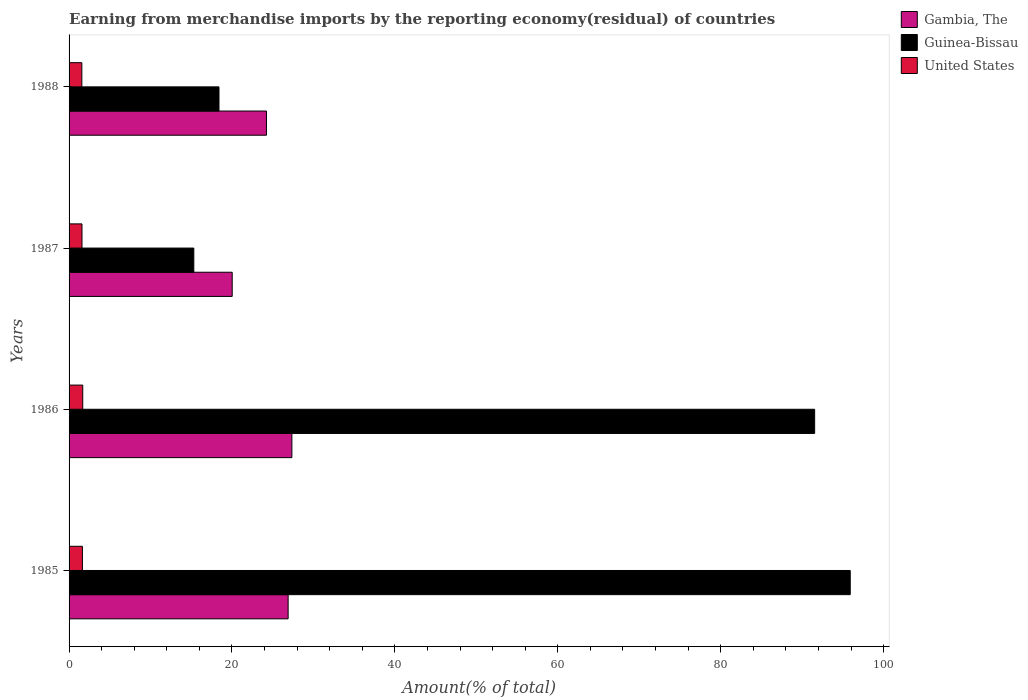How many different coloured bars are there?
Provide a short and direct response. 3. How many groups of bars are there?
Ensure brevity in your answer.  4. Are the number of bars per tick equal to the number of legend labels?
Your answer should be compact. Yes. Are the number of bars on each tick of the Y-axis equal?
Provide a succinct answer. Yes. How many bars are there on the 1st tick from the bottom?
Provide a short and direct response. 3. In how many cases, is the number of bars for a given year not equal to the number of legend labels?
Ensure brevity in your answer.  0. What is the percentage of amount earned from merchandise imports in Gambia, The in 1986?
Offer a terse response. 27.36. Across all years, what is the maximum percentage of amount earned from merchandise imports in United States?
Provide a short and direct response. 1.68. Across all years, what is the minimum percentage of amount earned from merchandise imports in United States?
Offer a terse response. 1.57. In which year was the percentage of amount earned from merchandise imports in United States minimum?
Offer a terse response. 1988. What is the total percentage of amount earned from merchandise imports in Guinea-Bissau in the graph?
Ensure brevity in your answer.  221.15. What is the difference between the percentage of amount earned from merchandise imports in United States in 1985 and that in 1986?
Make the answer very short. -0.04. What is the difference between the percentage of amount earned from merchandise imports in Gambia, The in 1988 and the percentage of amount earned from merchandise imports in Guinea-Bissau in 1986?
Offer a very short reply. -67.3. What is the average percentage of amount earned from merchandise imports in Gambia, The per year?
Give a very brief answer. 24.63. In the year 1985, what is the difference between the percentage of amount earned from merchandise imports in United States and percentage of amount earned from merchandise imports in Gambia, The?
Keep it short and to the point. -25.25. In how many years, is the percentage of amount earned from merchandise imports in Guinea-Bissau greater than 28 %?
Your answer should be compact. 2. What is the ratio of the percentage of amount earned from merchandise imports in United States in 1986 to that in 1988?
Ensure brevity in your answer.  1.07. Is the percentage of amount earned from merchandise imports in United States in 1986 less than that in 1988?
Offer a very short reply. No. What is the difference between the highest and the second highest percentage of amount earned from merchandise imports in Gambia, The?
Ensure brevity in your answer.  0.46. What is the difference between the highest and the lowest percentage of amount earned from merchandise imports in United States?
Your answer should be compact. 0.11. In how many years, is the percentage of amount earned from merchandise imports in Guinea-Bissau greater than the average percentage of amount earned from merchandise imports in Guinea-Bissau taken over all years?
Keep it short and to the point. 2. Is the sum of the percentage of amount earned from merchandise imports in Guinea-Bissau in 1987 and 1988 greater than the maximum percentage of amount earned from merchandise imports in United States across all years?
Keep it short and to the point. Yes. What does the 2nd bar from the top in 1988 represents?
Offer a terse response. Guinea-Bissau. What does the 2nd bar from the bottom in 1985 represents?
Keep it short and to the point. Guinea-Bissau. Is it the case that in every year, the sum of the percentage of amount earned from merchandise imports in United States and percentage of amount earned from merchandise imports in Gambia, The is greater than the percentage of amount earned from merchandise imports in Guinea-Bissau?
Make the answer very short. No. How many bars are there?
Provide a short and direct response. 12. What is the difference between two consecutive major ticks on the X-axis?
Ensure brevity in your answer.  20. Does the graph contain any zero values?
Provide a short and direct response. No. Does the graph contain grids?
Provide a succinct answer. No. Where does the legend appear in the graph?
Your answer should be compact. Top right. How many legend labels are there?
Offer a terse response. 3. How are the legend labels stacked?
Your answer should be very brief. Vertical. What is the title of the graph?
Provide a short and direct response. Earning from merchandise imports by the reporting economy(residual) of countries. Does "Botswana" appear as one of the legend labels in the graph?
Offer a terse response. No. What is the label or title of the X-axis?
Your answer should be very brief. Amount(% of total). What is the label or title of the Y-axis?
Make the answer very short. Years. What is the Amount(% of total) of Gambia, The in 1985?
Provide a short and direct response. 26.89. What is the Amount(% of total) of Guinea-Bissau in 1985?
Give a very brief answer. 95.9. What is the Amount(% of total) in United States in 1985?
Your answer should be compact. 1.64. What is the Amount(% of total) of Gambia, The in 1986?
Your answer should be compact. 27.36. What is the Amount(% of total) in Guinea-Bissau in 1986?
Offer a terse response. 91.53. What is the Amount(% of total) in United States in 1986?
Your response must be concise. 1.68. What is the Amount(% of total) of Gambia, The in 1987?
Your answer should be compact. 20.03. What is the Amount(% of total) of Guinea-Bissau in 1987?
Your response must be concise. 15.31. What is the Amount(% of total) in United States in 1987?
Your response must be concise. 1.59. What is the Amount(% of total) in Gambia, The in 1988?
Your response must be concise. 24.23. What is the Amount(% of total) of Guinea-Bissau in 1988?
Your answer should be very brief. 18.4. What is the Amount(% of total) of United States in 1988?
Keep it short and to the point. 1.57. Across all years, what is the maximum Amount(% of total) in Gambia, The?
Offer a very short reply. 27.36. Across all years, what is the maximum Amount(% of total) in Guinea-Bissau?
Your answer should be very brief. 95.9. Across all years, what is the maximum Amount(% of total) in United States?
Ensure brevity in your answer.  1.68. Across all years, what is the minimum Amount(% of total) in Gambia, The?
Provide a short and direct response. 20.03. Across all years, what is the minimum Amount(% of total) in Guinea-Bissau?
Offer a terse response. 15.31. Across all years, what is the minimum Amount(% of total) in United States?
Your response must be concise. 1.57. What is the total Amount(% of total) in Gambia, The in the graph?
Offer a terse response. 98.51. What is the total Amount(% of total) of Guinea-Bissau in the graph?
Offer a terse response. 221.15. What is the total Amount(% of total) in United States in the graph?
Make the answer very short. 6.47. What is the difference between the Amount(% of total) in Gambia, The in 1985 and that in 1986?
Offer a very short reply. -0.46. What is the difference between the Amount(% of total) in Guinea-Bissau in 1985 and that in 1986?
Keep it short and to the point. 4.37. What is the difference between the Amount(% of total) in United States in 1985 and that in 1986?
Provide a short and direct response. -0.04. What is the difference between the Amount(% of total) of Gambia, The in 1985 and that in 1987?
Keep it short and to the point. 6.87. What is the difference between the Amount(% of total) of Guinea-Bissau in 1985 and that in 1987?
Ensure brevity in your answer.  80.59. What is the difference between the Amount(% of total) of United States in 1985 and that in 1987?
Make the answer very short. 0.05. What is the difference between the Amount(% of total) in Gambia, The in 1985 and that in 1988?
Give a very brief answer. 2.66. What is the difference between the Amount(% of total) of Guinea-Bissau in 1985 and that in 1988?
Your answer should be compact. 77.5. What is the difference between the Amount(% of total) of United States in 1985 and that in 1988?
Offer a terse response. 0.07. What is the difference between the Amount(% of total) in Gambia, The in 1986 and that in 1987?
Keep it short and to the point. 7.33. What is the difference between the Amount(% of total) of Guinea-Bissau in 1986 and that in 1987?
Your answer should be compact. 76.22. What is the difference between the Amount(% of total) of United States in 1986 and that in 1987?
Make the answer very short. 0.09. What is the difference between the Amount(% of total) in Gambia, The in 1986 and that in 1988?
Give a very brief answer. 3.12. What is the difference between the Amount(% of total) in Guinea-Bissau in 1986 and that in 1988?
Provide a succinct answer. 73.13. What is the difference between the Amount(% of total) in United States in 1986 and that in 1988?
Give a very brief answer. 0.11. What is the difference between the Amount(% of total) in Gambia, The in 1987 and that in 1988?
Provide a succinct answer. -4.21. What is the difference between the Amount(% of total) of Guinea-Bissau in 1987 and that in 1988?
Offer a very short reply. -3.09. What is the difference between the Amount(% of total) in United States in 1987 and that in 1988?
Provide a short and direct response. 0.02. What is the difference between the Amount(% of total) in Gambia, The in 1985 and the Amount(% of total) in Guinea-Bissau in 1986?
Offer a very short reply. -64.64. What is the difference between the Amount(% of total) of Gambia, The in 1985 and the Amount(% of total) of United States in 1986?
Your answer should be very brief. 25.21. What is the difference between the Amount(% of total) in Guinea-Bissau in 1985 and the Amount(% of total) in United States in 1986?
Provide a succinct answer. 94.22. What is the difference between the Amount(% of total) of Gambia, The in 1985 and the Amount(% of total) of Guinea-Bissau in 1987?
Give a very brief answer. 11.58. What is the difference between the Amount(% of total) in Gambia, The in 1985 and the Amount(% of total) in United States in 1987?
Make the answer very short. 25.31. What is the difference between the Amount(% of total) in Guinea-Bissau in 1985 and the Amount(% of total) in United States in 1987?
Provide a succinct answer. 94.31. What is the difference between the Amount(% of total) in Gambia, The in 1985 and the Amount(% of total) in Guinea-Bissau in 1988?
Your answer should be compact. 8.49. What is the difference between the Amount(% of total) of Gambia, The in 1985 and the Amount(% of total) of United States in 1988?
Make the answer very short. 25.32. What is the difference between the Amount(% of total) of Guinea-Bissau in 1985 and the Amount(% of total) of United States in 1988?
Your response must be concise. 94.33. What is the difference between the Amount(% of total) in Gambia, The in 1986 and the Amount(% of total) in Guinea-Bissau in 1987?
Make the answer very short. 12.04. What is the difference between the Amount(% of total) of Gambia, The in 1986 and the Amount(% of total) of United States in 1987?
Your response must be concise. 25.77. What is the difference between the Amount(% of total) of Guinea-Bissau in 1986 and the Amount(% of total) of United States in 1987?
Your answer should be compact. 89.95. What is the difference between the Amount(% of total) of Gambia, The in 1986 and the Amount(% of total) of Guinea-Bissau in 1988?
Provide a succinct answer. 8.95. What is the difference between the Amount(% of total) in Gambia, The in 1986 and the Amount(% of total) in United States in 1988?
Your answer should be very brief. 25.79. What is the difference between the Amount(% of total) in Guinea-Bissau in 1986 and the Amount(% of total) in United States in 1988?
Your response must be concise. 89.96. What is the difference between the Amount(% of total) of Gambia, The in 1987 and the Amount(% of total) of Guinea-Bissau in 1988?
Give a very brief answer. 1.62. What is the difference between the Amount(% of total) of Gambia, The in 1987 and the Amount(% of total) of United States in 1988?
Make the answer very short. 18.46. What is the difference between the Amount(% of total) of Guinea-Bissau in 1987 and the Amount(% of total) of United States in 1988?
Make the answer very short. 13.75. What is the average Amount(% of total) in Gambia, The per year?
Your answer should be compact. 24.63. What is the average Amount(% of total) in Guinea-Bissau per year?
Offer a very short reply. 55.29. What is the average Amount(% of total) of United States per year?
Make the answer very short. 1.62. In the year 1985, what is the difference between the Amount(% of total) of Gambia, The and Amount(% of total) of Guinea-Bissau?
Ensure brevity in your answer.  -69.01. In the year 1985, what is the difference between the Amount(% of total) of Gambia, The and Amount(% of total) of United States?
Your answer should be very brief. 25.25. In the year 1985, what is the difference between the Amount(% of total) of Guinea-Bissau and Amount(% of total) of United States?
Offer a very short reply. 94.26. In the year 1986, what is the difference between the Amount(% of total) of Gambia, The and Amount(% of total) of Guinea-Bissau?
Make the answer very short. -64.18. In the year 1986, what is the difference between the Amount(% of total) of Gambia, The and Amount(% of total) of United States?
Ensure brevity in your answer.  25.68. In the year 1986, what is the difference between the Amount(% of total) in Guinea-Bissau and Amount(% of total) in United States?
Your answer should be compact. 89.85. In the year 1987, what is the difference between the Amount(% of total) in Gambia, The and Amount(% of total) in Guinea-Bissau?
Make the answer very short. 4.71. In the year 1987, what is the difference between the Amount(% of total) in Gambia, The and Amount(% of total) in United States?
Provide a short and direct response. 18.44. In the year 1987, what is the difference between the Amount(% of total) in Guinea-Bissau and Amount(% of total) in United States?
Give a very brief answer. 13.73. In the year 1988, what is the difference between the Amount(% of total) of Gambia, The and Amount(% of total) of Guinea-Bissau?
Keep it short and to the point. 5.83. In the year 1988, what is the difference between the Amount(% of total) of Gambia, The and Amount(% of total) of United States?
Offer a terse response. 22.66. In the year 1988, what is the difference between the Amount(% of total) in Guinea-Bissau and Amount(% of total) in United States?
Keep it short and to the point. 16.84. What is the ratio of the Amount(% of total) in Gambia, The in 1985 to that in 1986?
Your answer should be compact. 0.98. What is the ratio of the Amount(% of total) in Guinea-Bissau in 1985 to that in 1986?
Your answer should be compact. 1.05. What is the ratio of the Amount(% of total) in United States in 1985 to that in 1986?
Your response must be concise. 0.98. What is the ratio of the Amount(% of total) in Gambia, The in 1985 to that in 1987?
Provide a short and direct response. 1.34. What is the ratio of the Amount(% of total) in Guinea-Bissau in 1985 to that in 1987?
Make the answer very short. 6.26. What is the ratio of the Amount(% of total) of United States in 1985 to that in 1987?
Provide a succinct answer. 1.03. What is the ratio of the Amount(% of total) of Gambia, The in 1985 to that in 1988?
Keep it short and to the point. 1.11. What is the ratio of the Amount(% of total) in Guinea-Bissau in 1985 to that in 1988?
Your answer should be compact. 5.21. What is the ratio of the Amount(% of total) in United States in 1985 to that in 1988?
Provide a succinct answer. 1.05. What is the ratio of the Amount(% of total) of Gambia, The in 1986 to that in 1987?
Your answer should be very brief. 1.37. What is the ratio of the Amount(% of total) of Guinea-Bissau in 1986 to that in 1987?
Provide a short and direct response. 5.98. What is the ratio of the Amount(% of total) in United States in 1986 to that in 1987?
Ensure brevity in your answer.  1.06. What is the ratio of the Amount(% of total) in Gambia, The in 1986 to that in 1988?
Your answer should be very brief. 1.13. What is the ratio of the Amount(% of total) in Guinea-Bissau in 1986 to that in 1988?
Your answer should be very brief. 4.97. What is the ratio of the Amount(% of total) in United States in 1986 to that in 1988?
Offer a terse response. 1.07. What is the ratio of the Amount(% of total) in Gambia, The in 1987 to that in 1988?
Keep it short and to the point. 0.83. What is the ratio of the Amount(% of total) of Guinea-Bissau in 1987 to that in 1988?
Keep it short and to the point. 0.83. What is the difference between the highest and the second highest Amount(% of total) in Gambia, The?
Your answer should be compact. 0.46. What is the difference between the highest and the second highest Amount(% of total) of Guinea-Bissau?
Provide a short and direct response. 4.37. What is the difference between the highest and the second highest Amount(% of total) of United States?
Your answer should be compact. 0.04. What is the difference between the highest and the lowest Amount(% of total) of Gambia, The?
Offer a terse response. 7.33. What is the difference between the highest and the lowest Amount(% of total) of Guinea-Bissau?
Your answer should be compact. 80.59. What is the difference between the highest and the lowest Amount(% of total) of United States?
Your answer should be compact. 0.11. 